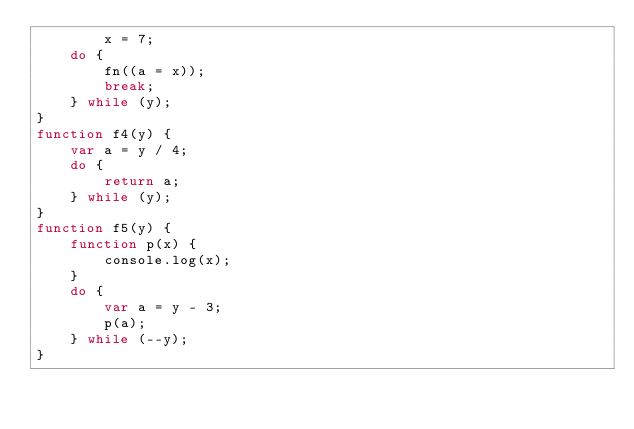Convert code to text. <code><loc_0><loc_0><loc_500><loc_500><_JavaScript_>        x = 7;
    do {
        fn((a = x));
        break;
    } while (y);
}
function f4(y) {
    var a = y / 4;
    do {
        return a;
    } while (y);
}
function f5(y) {
    function p(x) {
        console.log(x);
    }
    do {
        var a = y - 3;
        p(a);
    } while (--y);
}
</code> 